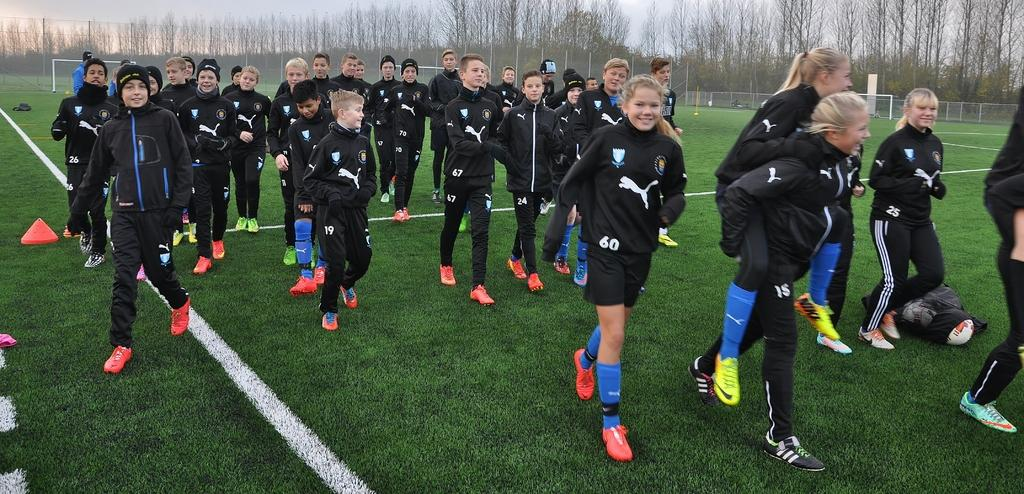What can be seen in the background of the image? In the background of the image, there is a sky, trees, and a fence. What type of terrain is visible in the image? Grass is present in the image, indicating a grassy terrain. What structures are present in the image? There are poles in the image. What are the people in the image wearing? The people in the image are wearing jackets and shoes. How many servants are visible in the image? There are no servants present in the image. Can you tell me the name of the friend in the image? There is no friend mentioned or visible in the image. 